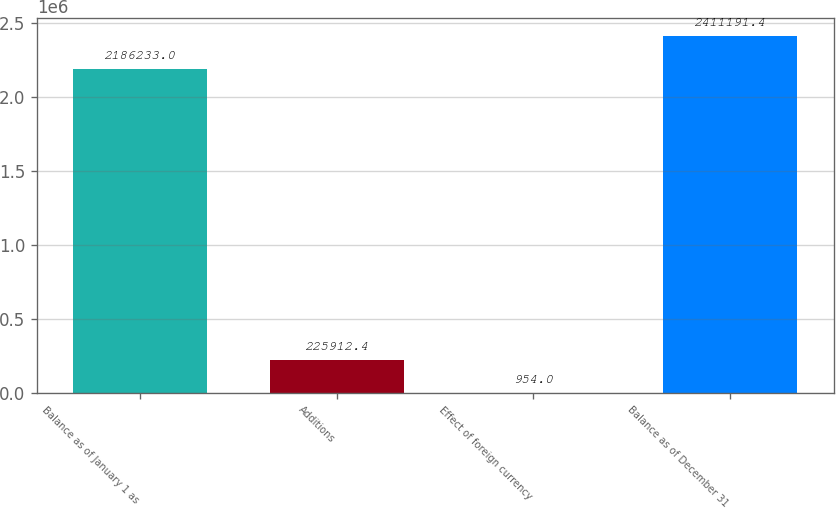Convert chart. <chart><loc_0><loc_0><loc_500><loc_500><bar_chart><fcel>Balance as of January 1 as<fcel>Additions<fcel>Effect of foreign currency<fcel>Balance as of December 31<nl><fcel>2.18623e+06<fcel>225912<fcel>954<fcel>2.41119e+06<nl></chart> 